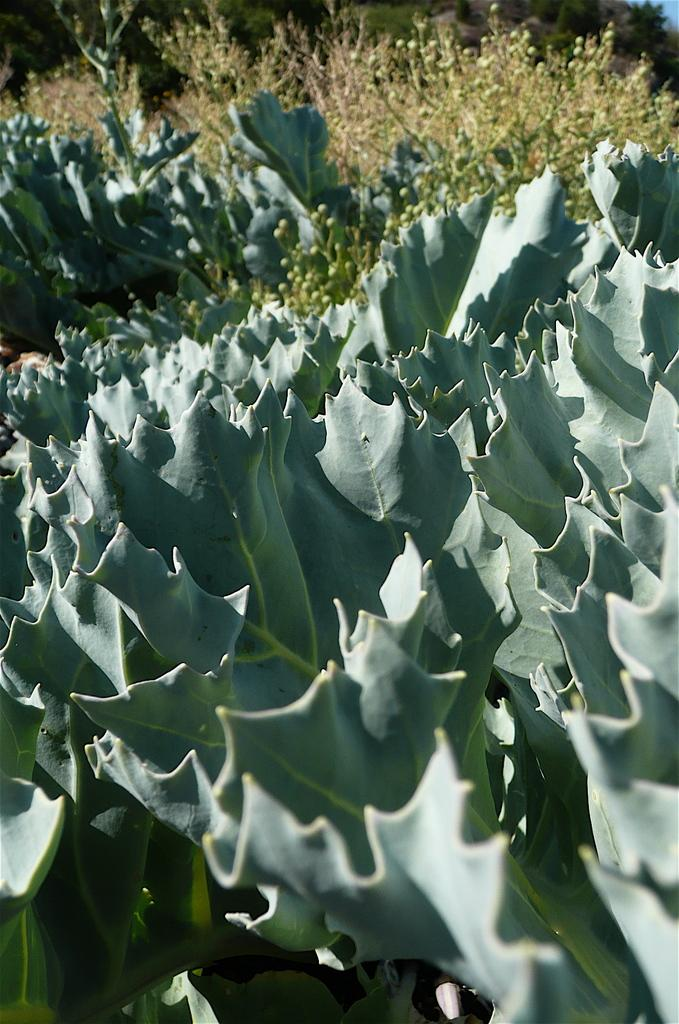What type of living organisms can be seen in the image? Plants can be seen in the image. What type of vest is being worn by the pickle in the image? There are no pickles or vests present in the image; it only features plants. 